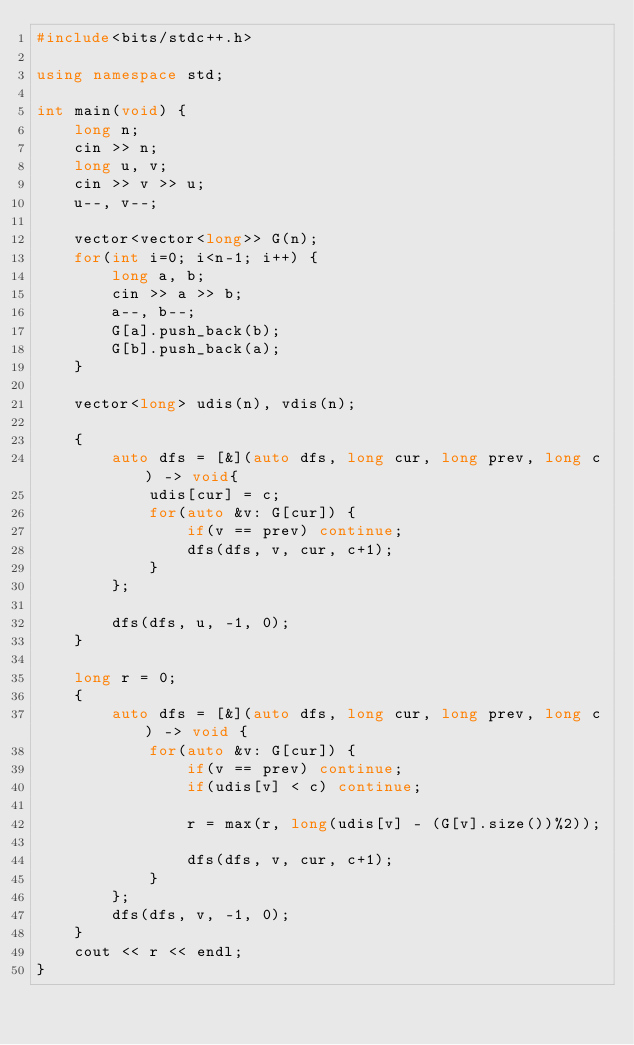<code> <loc_0><loc_0><loc_500><loc_500><_C++_>#include<bits/stdc++.h>

using namespace std;

int main(void) {
    long n;
    cin >> n;
    long u, v;
    cin >> v >> u;
    u--, v--;

    vector<vector<long>> G(n);
    for(int i=0; i<n-1; i++) {
        long a, b;
        cin >> a >> b;
        a--, b--;
        G[a].push_back(b);
        G[b].push_back(a);
    }

    vector<long> udis(n), vdis(n);

    {
        auto dfs = [&](auto dfs, long cur, long prev, long c) -> void{
            udis[cur] = c;
            for(auto &v: G[cur]) {
                if(v == prev) continue;
                dfs(dfs, v, cur, c+1);
            }
        };

        dfs(dfs, u, -1, 0);
    }

    long r = 0;
    {
        auto dfs = [&](auto dfs, long cur, long prev, long c) -> void {
            for(auto &v: G[cur]) {
                if(v == prev) continue;
                if(udis[v] < c) continue;

                r = max(r, long(udis[v] - (G[v].size())%2));

                dfs(dfs, v, cur, c+1);
            }
        };
        dfs(dfs, v, -1, 0);
    }
    cout << r << endl;
}
</code> 